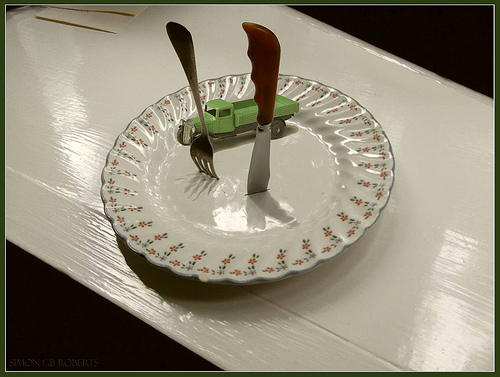<image>
Can you confirm if the truck is on the road? No. The truck is not positioned on the road. They may be near each other, but the truck is not supported by or resting on top of the road. 